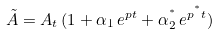<formula> <loc_0><loc_0><loc_500><loc_500>\tilde { A } = A _ { t } \, ( 1 + \alpha _ { 1 } \, e ^ { p t } + \alpha _ { 2 } ^ { ^ { * } } \, e ^ { p ^ { ^ { * } } t } )</formula> 